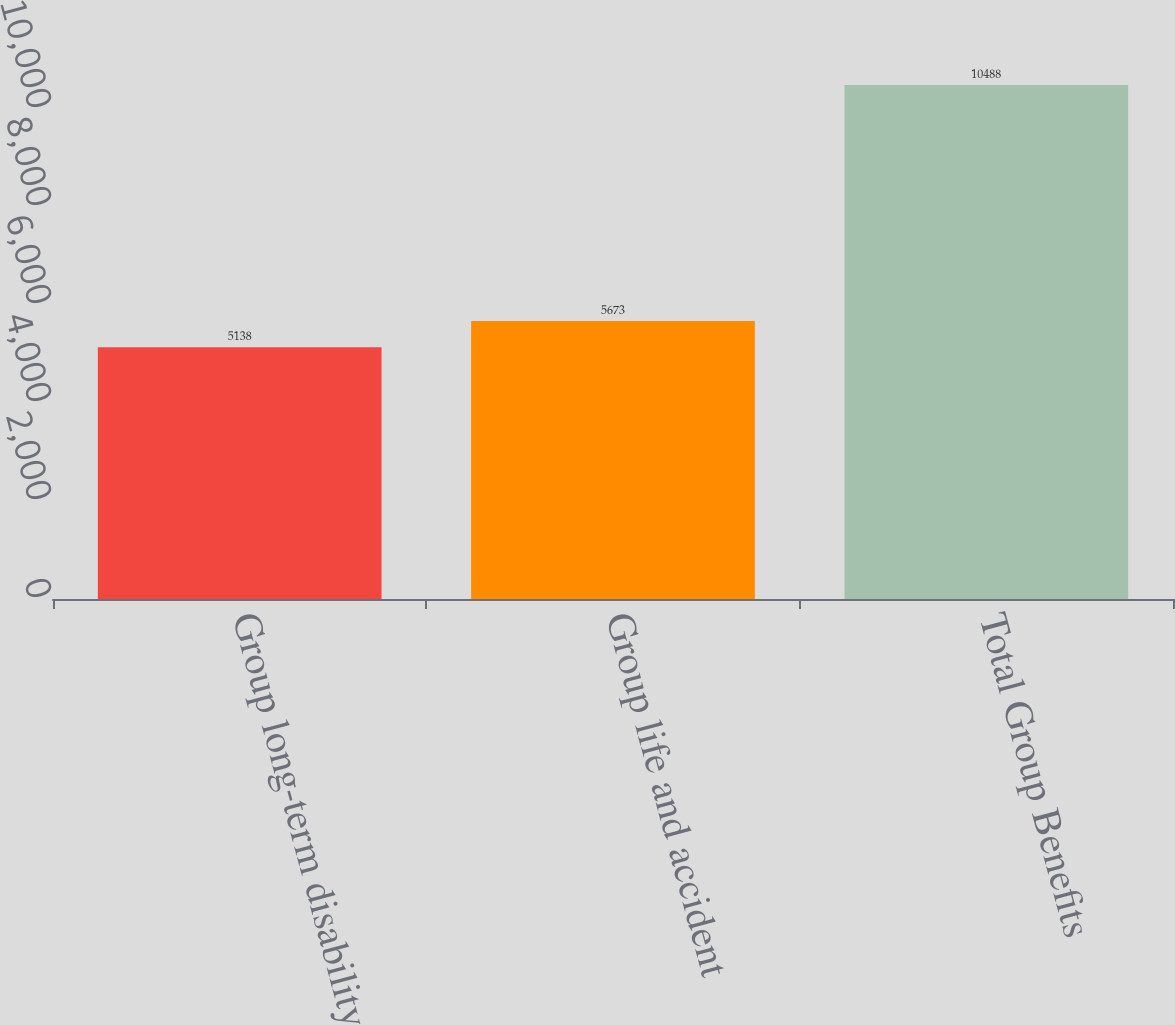Convert chart to OTSL. <chart><loc_0><loc_0><loc_500><loc_500><bar_chart><fcel>Group long-term disability<fcel>Group life and accident<fcel>Total Group Benefits<nl><fcel>5138<fcel>5673<fcel>10488<nl></chart> 